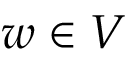Convert formula to latex. <formula><loc_0><loc_0><loc_500><loc_500>w \in V</formula> 